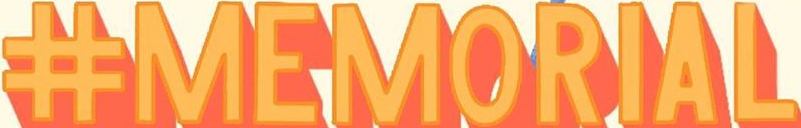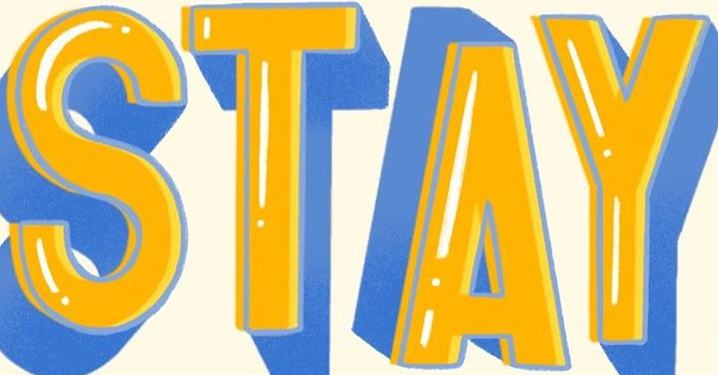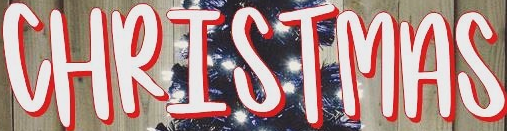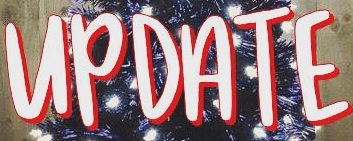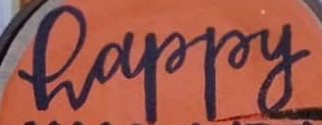What text appears in these images from left to right, separated by a semicolon? #MEMORIAL; STAY; CHRISTMAS; UPDATE; happy 